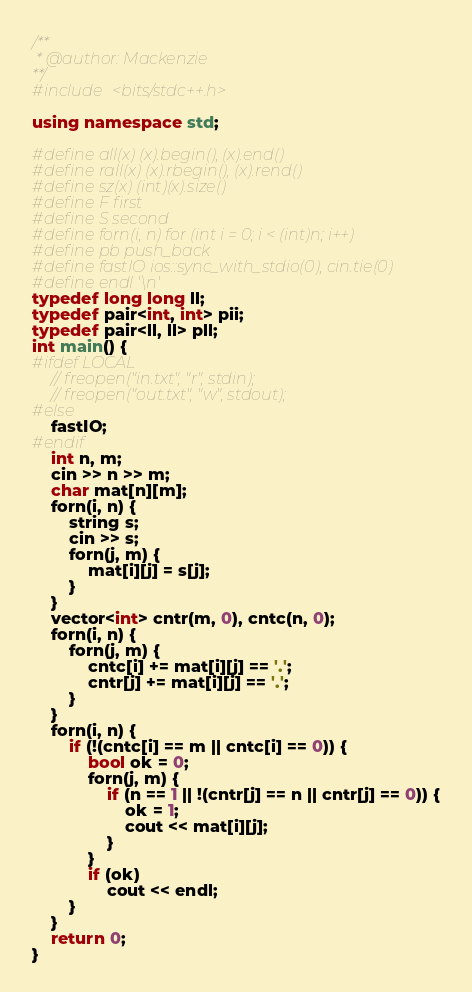<code> <loc_0><loc_0><loc_500><loc_500><_C++_>/**
 * @author: Mackenzie
**/
#include <bits/stdc++.h>

using namespace std;

#define all(x) (x).begin(), (x).end()
#define rall(x) (x).rbegin(), (x).rend()
#define sz(x) (int)(x).size()
#define F first
#define S second
#define forn(i, n) for (int i = 0; i < (int)n; i++)
#define pb push_back
#define fastIO ios::sync_with_stdio(0), cin.tie(0)
#define endl '\n'
typedef long long ll;
typedef pair<int, int> pii;
typedef pair<ll, ll> pll;
int main() {
#ifdef LOCAL
    // freopen("in.txt", "r", stdin);
    // freopen("out.txt", "w", stdout);
#else
    fastIO;
#endif
    int n, m;
    cin >> n >> m;
    char mat[n][m];
    forn(i, n) {
        string s;
        cin >> s;
        forn(j, m) {
            mat[i][j] = s[j];
        }
    }
    vector<int> cntr(m, 0), cntc(n, 0);
    forn(i, n) {
        forn(j, m) {
            cntc[i] += mat[i][j] == '.';
            cntr[j] += mat[i][j] == '.';
        }
    }
    forn(i, n) {
        if (!(cntc[i] == m || cntc[i] == 0)) {
            bool ok = 0;
            forn(j, m) {
                if (n == 1 || !(cntr[j] == n || cntr[j] == 0)) {
                    ok = 1;
                    cout << mat[i][j];
                }
            }
            if (ok)
                cout << endl;
        }
    }
    return 0;
}</code> 